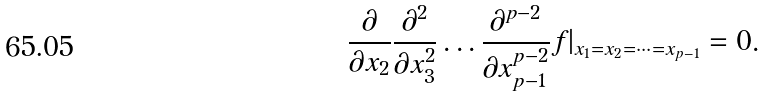Convert formula to latex. <formula><loc_0><loc_0><loc_500><loc_500>\frac { \partial } { \partial x _ { 2 } } \frac { \partial ^ { 2 } } { \partial x _ { 3 } ^ { 2 } } \dots \frac { \partial ^ { p - 2 } } { \partial x _ { p - 1 } ^ { p - 2 } } f | _ { x _ { 1 } = x _ { 2 } = \dots = x _ { p - 1 } } = 0 .</formula> 